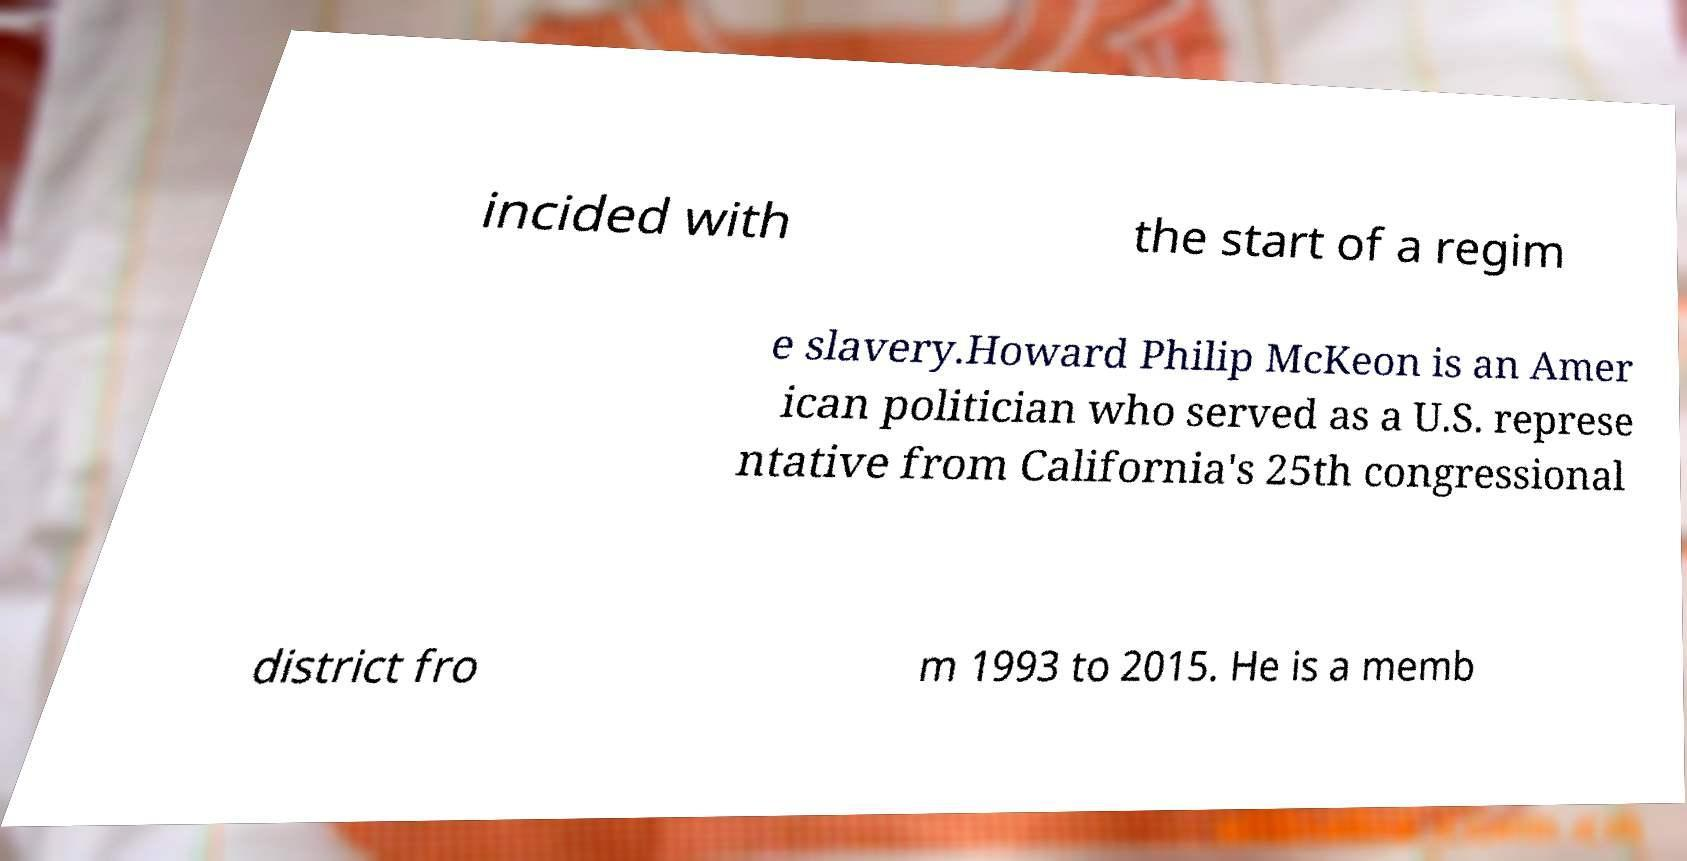There's text embedded in this image that I need extracted. Can you transcribe it verbatim? incided with the start of a regim e slavery.Howard Philip McKeon is an Amer ican politician who served as a U.S. represe ntative from California's 25th congressional district fro m 1993 to 2015. He is a memb 